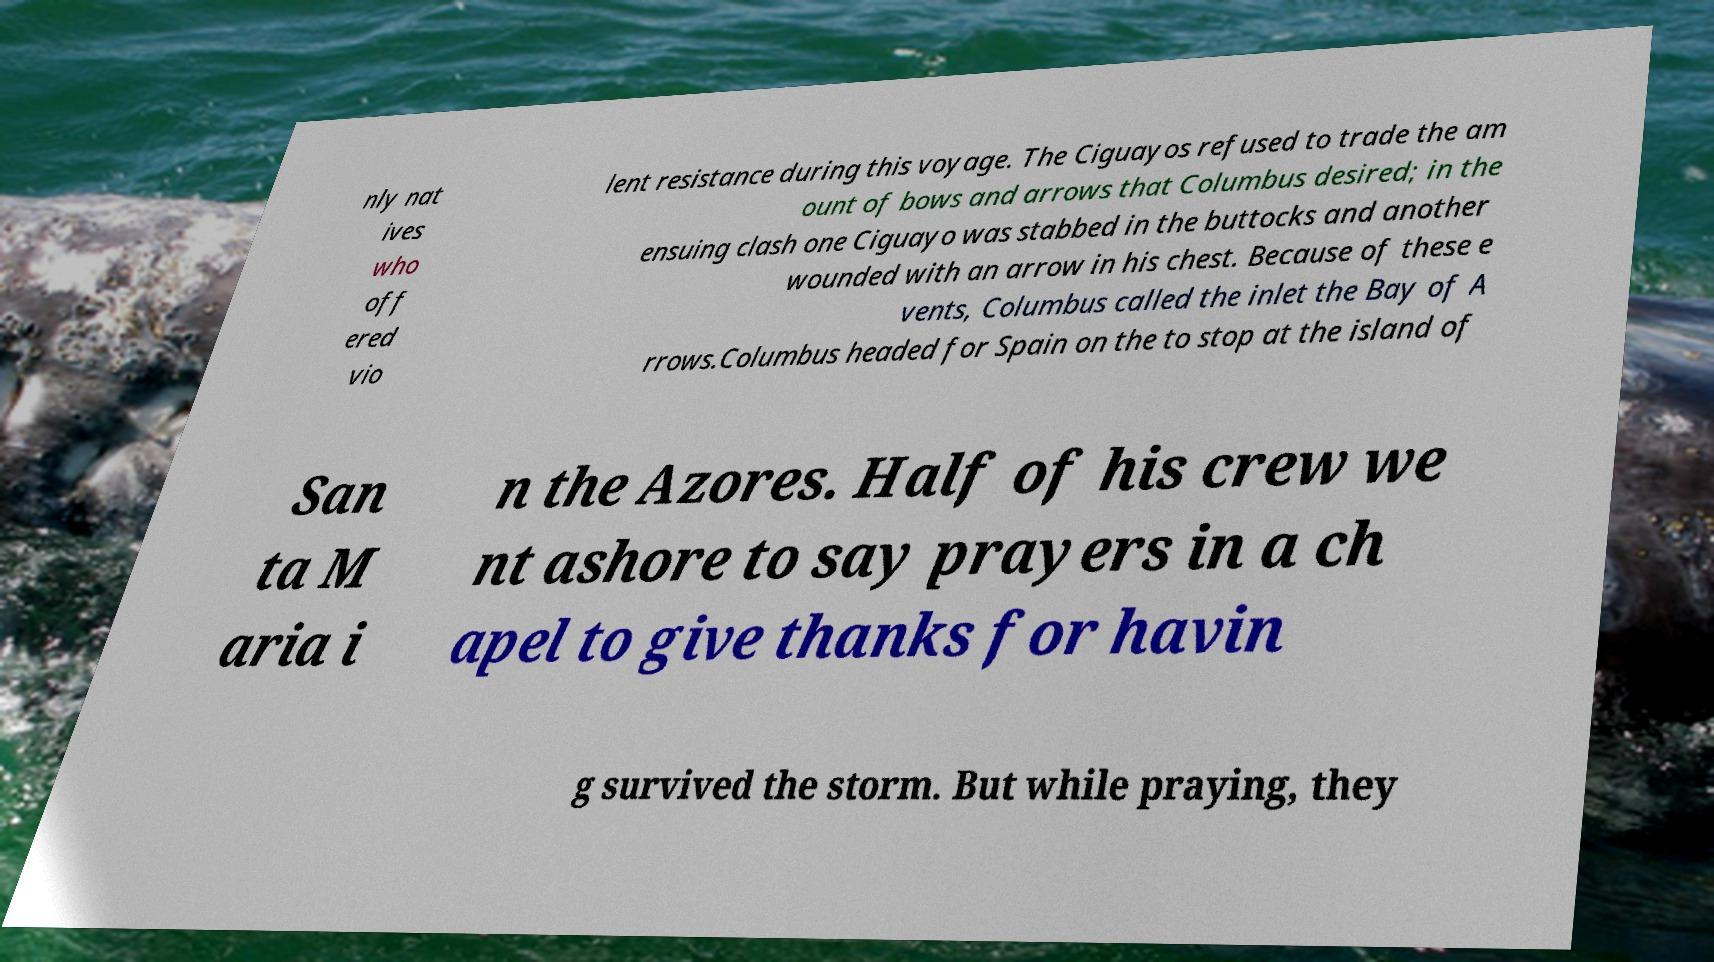Could you extract and type out the text from this image? nly nat ives who off ered vio lent resistance during this voyage. The Ciguayos refused to trade the am ount of bows and arrows that Columbus desired; in the ensuing clash one Ciguayo was stabbed in the buttocks and another wounded with an arrow in his chest. Because of these e vents, Columbus called the inlet the Bay of A rrows.Columbus headed for Spain on the to stop at the island of San ta M aria i n the Azores. Half of his crew we nt ashore to say prayers in a ch apel to give thanks for havin g survived the storm. But while praying, they 